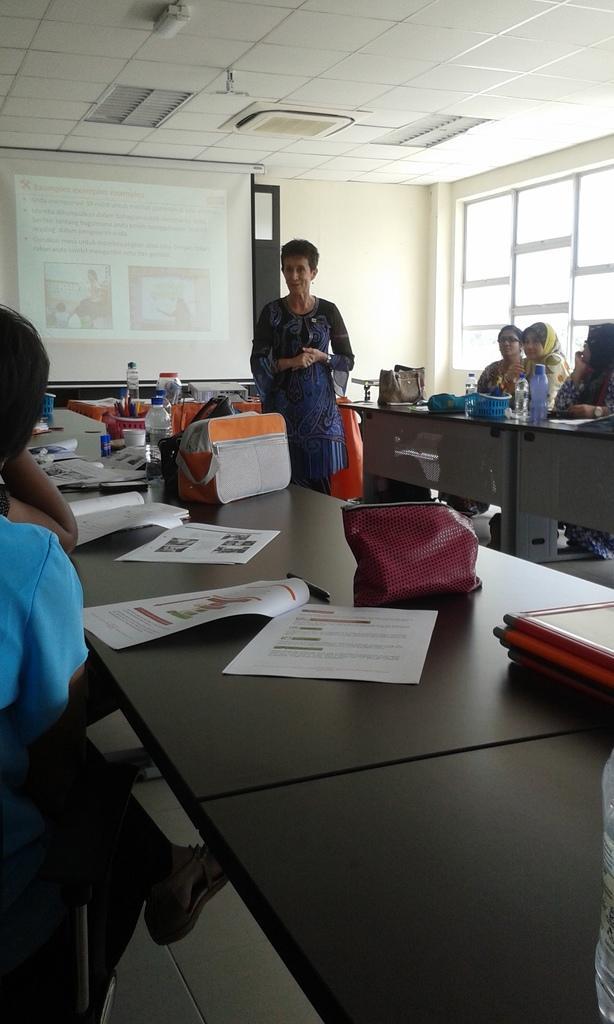How would you summarize this image in a sentence or two? This picture is clicked in a room. There are two persons sitting besides a table towards the left. On the table there are some papers, bottles and bags. Towards the right there is another table and three people are sitting beside it. In the middle there is a woman and she is wearing a blue dress. In the left there is a projector, in the top there is a ceiling. 